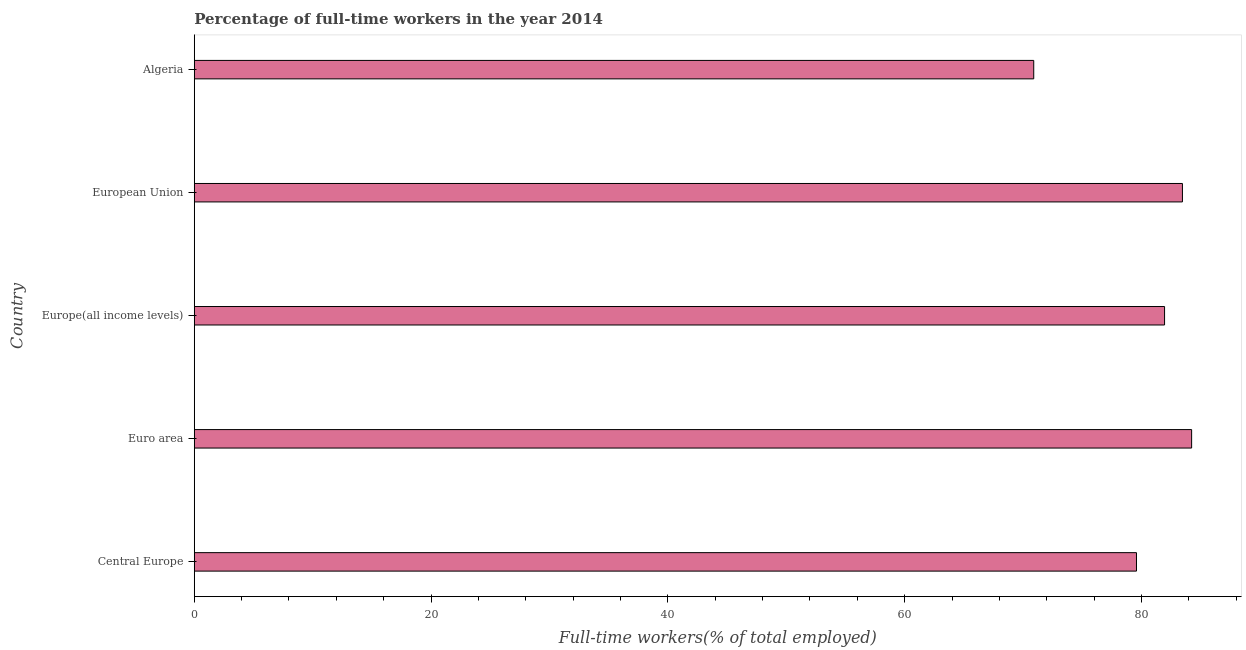Does the graph contain any zero values?
Offer a very short reply. No. Does the graph contain grids?
Your answer should be very brief. No. What is the title of the graph?
Your response must be concise. Percentage of full-time workers in the year 2014. What is the label or title of the X-axis?
Keep it short and to the point. Full-time workers(% of total employed). What is the label or title of the Y-axis?
Your answer should be very brief. Country. What is the percentage of full-time workers in Euro area?
Make the answer very short. 84.24. Across all countries, what is the maximum percentage of full-time workers?
Your response must be concise. 84.24. Across all countries, what is the minimum percentage of full-time workers?
Provide a succinct answer. 70.9. In which country was the percentage of full-time workers maximum?
Offer a very short reply. Euro area. In which country was the percentage of full-time workers minimum?
Offer a terse response. Algeria. What is the sum of the percentage of full-time workers?
Ensure brevity in your answer.  400.12. What is the difference between the percentage of full-time workers in Central Europe and Euro area?
Offer a very short reply. -4.66. What is the average percentage of full-time workers per country?
Your answer should be very brief. 80.03. What is the median percentage of full-time workers?
Provide a short and direct response. 81.95. In how many countries, is the percentage of full-time workers greater than 60 %?
Offer a terse response. 5. What is the ratio of the percentage of full-time workers in Central Europe to that in European Union?
Provide a short and direct response. 0.95. Is the percentage of full-time workers in Algeria less than that in Euro area?
Your answer should be very brief. Yes. Is the difference between the percentage of full-time workers in Algeria and Central Europe greater than the difference between any two countries?
Your response must be concise. No. What is the difference between the highest and the second highest percentage of full-time workers?
Offer a very short reply. 0.78. Is the sum of the percentage of full-time workers in Central Europe and Euro area greater than the maximum percentage of full-time workers across all countries?
Provide a short and direct response. Yes. What is the difference between the highest and the lowest percentage of full-time workers?
Your response must be concise. 13.34. In how many countries, is the percentage of full-time workers greater than the average percentage of full-time workers taken over all countries?
Give a very brief answer. 3. How many bars are there?
Ensure brevity in your answer.  5. Are all the bars in the graph horizontal?
Your answer should be compact. Yes. How many countries are there in the graph?
Your answer should be very brief. 5. What is the difference between two consecutive major ticks on the X-axis?
Your answer should be very brief. 20. What is the Full-time workers(% of total employed) in Central Europe?
Your response must be concise. 79.58. What is the Full-time workers(% of total employed) of Euro area?
Your response must be concise. 84.24. What is the Full-time workers(% of total employed) in Europe(all income levels)?
Offer a terse response. 81.95. What is the Full-time workers(% of total employed) in European Union?
Ensure brevity in your answer.  83.46. What is the Full-time workers(% of total employed) in Algeria?
Keep it short and to the point. 70.9. What is the difference between the Full-time workers(% of total employed) in Central Europe and Euro area?
Offer a terse response. -4.66. What is the difference between the Full-time workers(% of total employed) in Central Europe and Europe(all income levels)?
Provide a short and direct response. -2.37. What is the difference between the Full-time workers(% of total employed) in Central Europe and European Union?
Your answer should be very brief. -3.88. What is the difference between the Full-time workers(% of total employed) in Central Europe and Algeria?
Keep it short and to the point. 8.68. What is the difference between the Full-time workers(% of total employed) in Euro area and Europe(all income levels)?
Make the answer very short. 2.29. What is the difference between the Full-time workers(% of total employed) in Euro area and European Union?
Your answer should be very brief. 0.78. What is the difference between the Full-time workers(% of total employed) in Euro area and Algeria?
Your response must be concise. 13.34. What is the difference between the Full-time workers(% of total employed) in Europe(all income levels) and European Union?
Ensure brevity in your answer.  -1.51. What is the difference between the Full-time workers(% of total employed) in Europe(all income levels) and Algeria?
Your answer should be compact. 11.05. What is the difference between the Full-time workers(% of total employed) in European Union and Algeria?
Make the answer very short. 12.56. What is the ratio of the Full-time workers(% of total employed) in Central Europe to that in Euro area?
Ensure brevity in your answer.  0.94. What is the ratio of the Full-time workers(% of total employed) in Central Europe to that in European Union?
Your answer should be compact. 0.95. What is the ratio of the Full-time workers(% of total employed) in Central Europe to that in Algeria?
Ensure brevity in your answer.  1.12. What is the ratio of the Full-time workers(% of total employed) in Euro area to that in Europe(all income levels)?
Make the answer very short. 1.03. What is the ratio of the Full-time workers(% of total employed) in Euro area to that in European Union?
Offer a terse response. 1.01. What is the ratio of the Full-time workers(% of total employed) in Euro area to that in Algeria?
Make the answer very short. 1.19. What is the ratio of the Full-time workers(% of total employed) in Europe(all income levels) to that in Algeria?
Give a very brief answer. 1.16. What is the ratio of the Full-time workers(% of total employed) in European Union to that in Algeria?
Give a very brief answer. 1.18. 